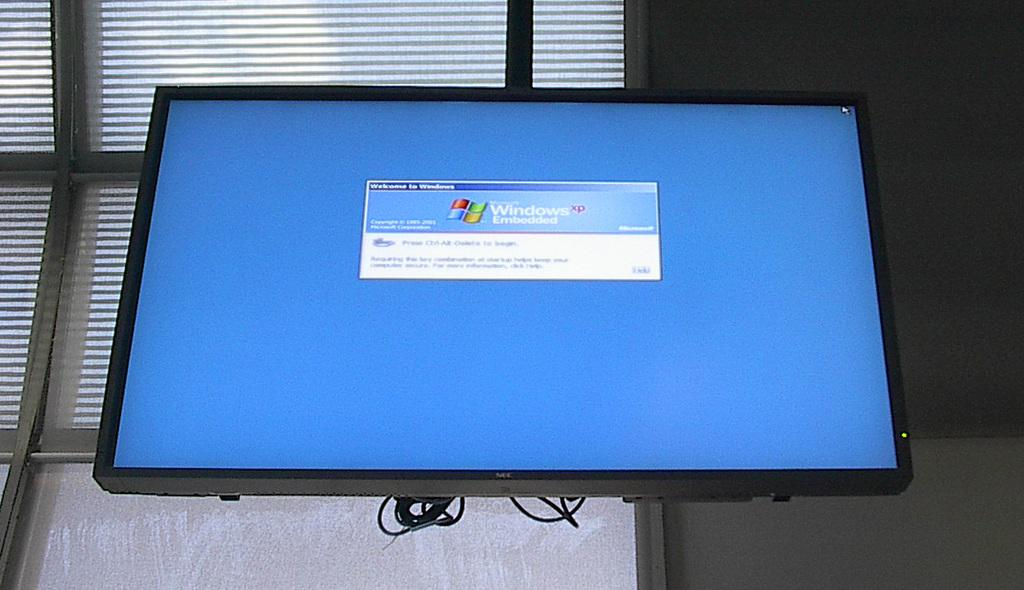Provide a one-sentence caption for the provided image. On the computer screen there is a message welcoming the person to windows. 